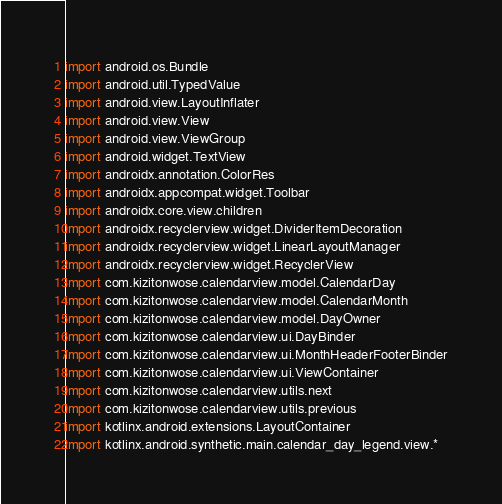Convert code to text. <code><loc_0><loc_0><loc_500><loc_500><_Kotlin_>
import android.os.Bundle
import android.util.TypedValue
import android.view.LayoutInflater
import android.view.View
import android.view.ViewGroup
import android.widget.TextView
import androidx.annotation.ColorRes
import androidx.appcompat.widget.Toolbar
import androidx.core.view.children
import androidx.recyclerview.widget.DividerItemDecoration
import androidx.recyclerview.widget.LinearLayoutManager
import androidx.recyclerview.widget.RecyclerView
import com.kizitonwose.calendarview.model.CalendarDay
import com.kizitonwose.calendarview.model.CalendarMonth
import com.kizitonwose.calendarview.model.DayOwner
import com.kizitonwose.calendarview.ui.DayBinder
import com.kizitonwose.calendarview.ui.MonthHeaderFooterBinder
import com.kizitonwose.calendarview.ui.ViewContainer
import com.kizitonwose.calendarview.utils.next
import com.kizitonwose.calendarview.utils.previous
import kotlinx.android.extensions.LayoutContainer
import kotlinx.android.synthetic.main.calendar_day_legend.view.*</code> 